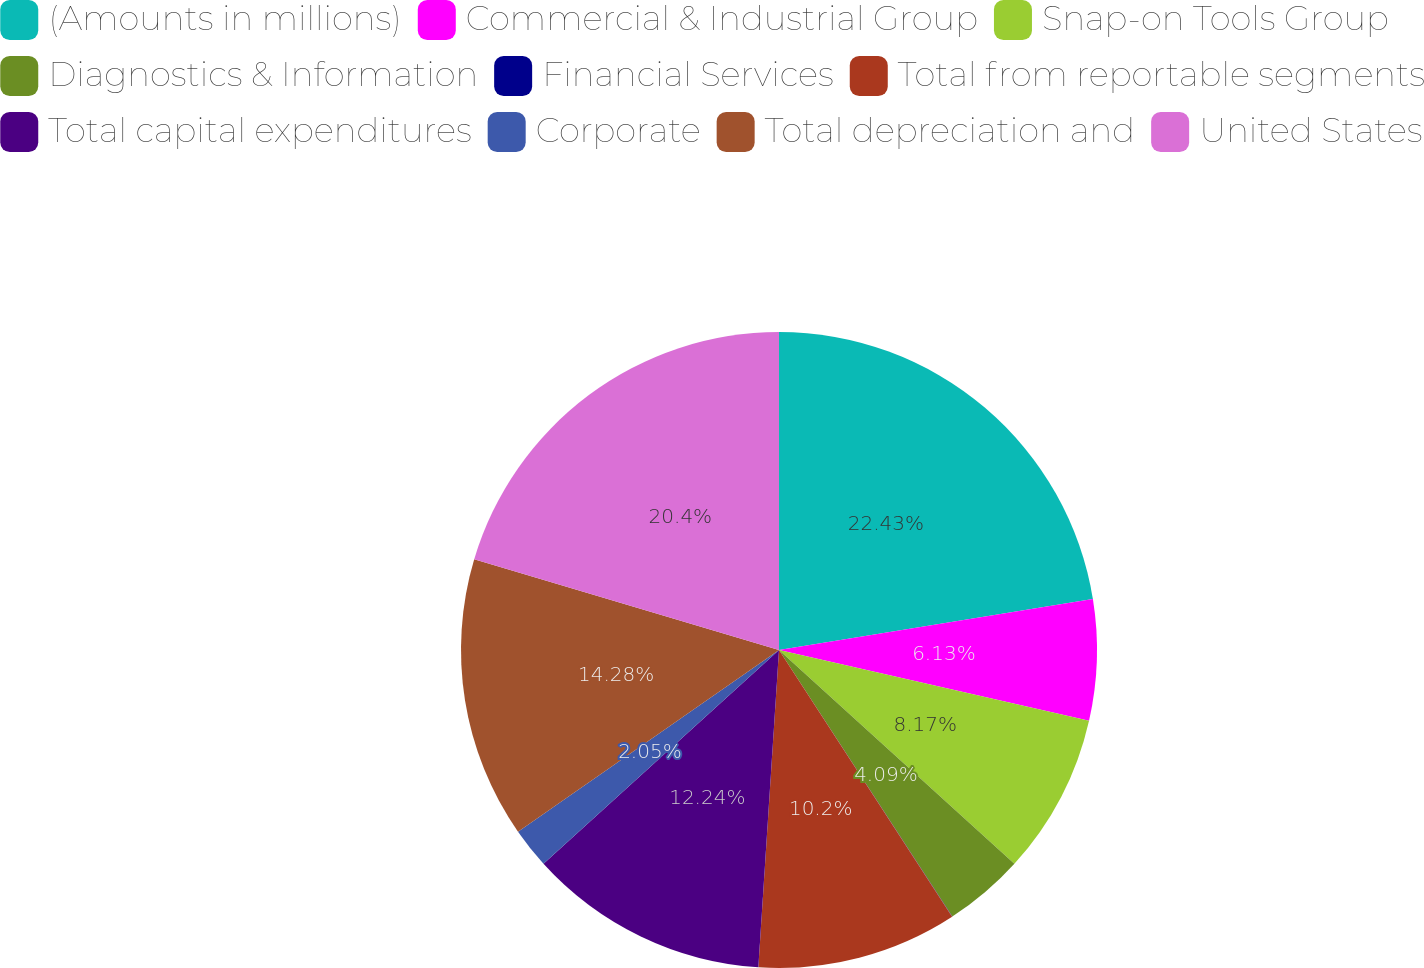<chart> <loc_0><loc_0><loc_500><loc_500><pie_chart><fcel>(Amounts in millions)<fcel>Commercial & Industrial Group<fcel>Snap-on Tools Group<fcel>Diagnostics & Information<fcel>Financial Services<fcel>Total from reportable segments<fcel>Total capital expenditures<fcel>Corporate<fcel>Total depreciation and<fcel>United States<nl><fcel>22.44%<fcel>6.13%<fcel>8.17%<fcel>4.09%<fcel>0.01%<fcel>10.2%<fcel>12.24%<fcel>2.05%<fcel>14.28%<fcel>20.4%<nl></chart> 